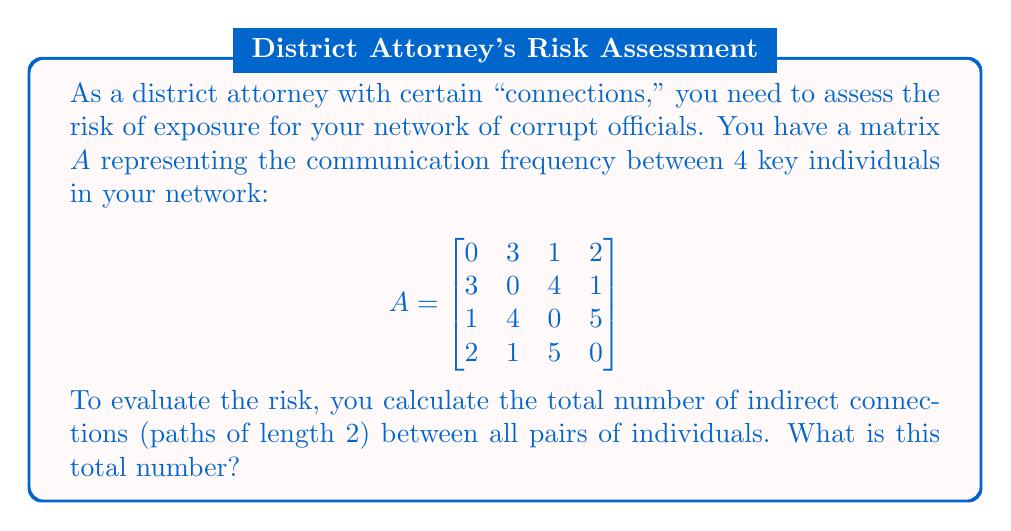Provide a solution to this math problem. To solve this problem, we need to follow these steps:

1) In a network analysis, the number of paths of length 2 between all pairs of nodes is given by the sum of all elements in the square of the adjacency matrix.

2) We need to calculate $A^2$:

   $$A^2 = \begin{bmatrix}
   0 & 3 & 1 & 2 \\
   3 & 0 & 4 & 1 \\
   1 & 4 & 0 & 5 \\
   2 & 1 & 5 & 0
   \end{bmatrix} \times 
   \begin{bmatrix}
   0 & 3 & 1 & 2 \\
   3 & 0 & 4 & 1 \\
   1 & 4 & 0 & 5 \\
   2 & 1 & 5 & 0
   \end{bmatrix}$$

3) Performing the matrix multiplication:

   $$A^2 = \begin{bmatrix}
   14 & 7 & 23 & 7 \\
   7 & 26 & 7 & 25 \\
   23 & 7 & 42 & 9 \\
   7 & 25 & 9 & 30
   \end{bmatrix}$$

4) The total number of indirect connections is the sum of all elements in $A^2$:

   $14 + 7 + 23 + 7 + 7 + 26 + 7 + 25 + 23 + 7 + 42 + 9 + 7 + 25 + 9 + 30 = 268$

Therefore, the total number of indirect connections (paths of length 2) between all pairs of individuals in your network is 268.
Answer: 268 